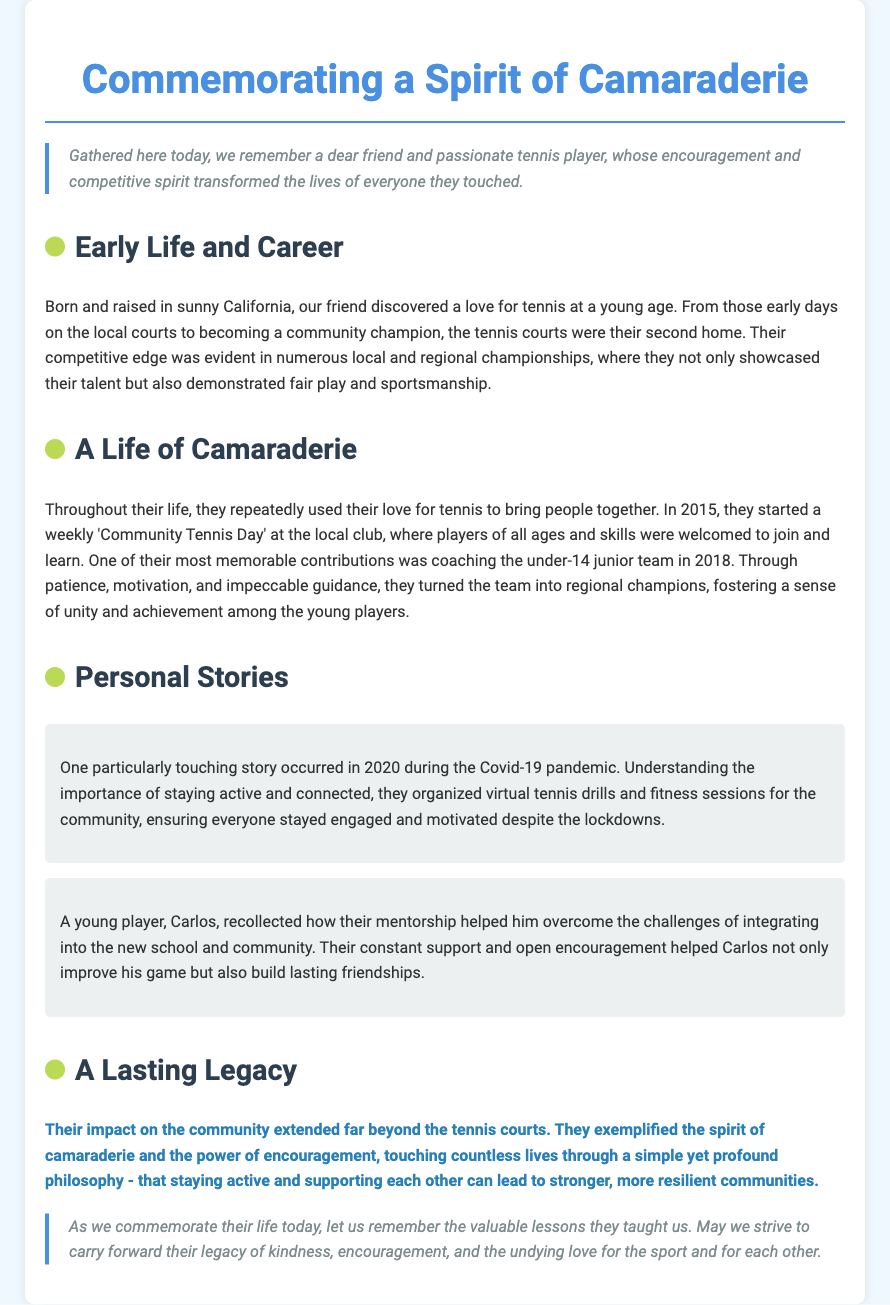What was the location of the friend's early life? The document states that they were born and raised in sunny California.
Answer: California What year did they start the 'Community Tennis Day'? The document mentions that this initiative began in 2015.
Answer: 2015 Who did they coach in 2018? It specifies that they coached the under-14 junior team.
Answer: under-14 junior team What did they organize during the Covid-19 pandemic? The document describes that they organized virtual tennis drills and fitness sessions.
Answer: virtual tennis drills How did Carlos benefit from their mentorship? The document notes that Carlos improved his game and built lasting friendships.
Answer: improved his game What does the document emphasize about their legacy? It highlights that they exemplified the spirit of camaraderie and the power of encouragement.
Answer: spirit of camaraderie Who is commemorated in this eulogy? The eulogy is commemorating a dear friend and passionate tennis player.
Answer: dear friend What was a key contribution to the community made in 2018? The document recounts that their coaching turned the junior team into regional champions.
Answer: regional champions What character quality did the friend consistently show? They are described as having a competitive edge along with fair play and sportsmanship.
Answer: fair play 